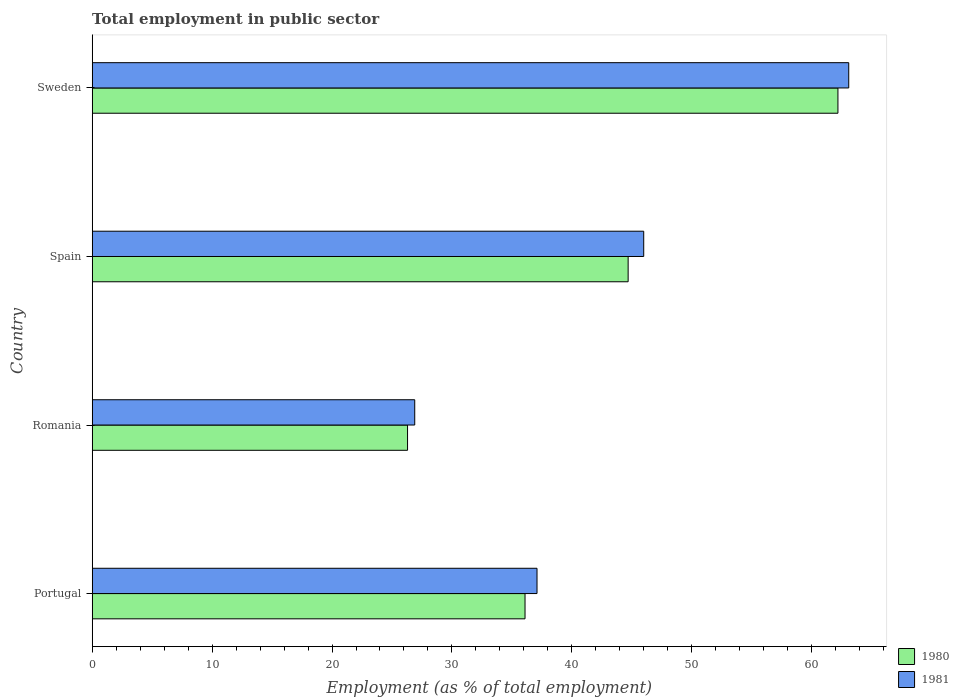How many different coloured bars are there?
Offer a terse response. 2. Are the number of bars on each tick of the Y-axis equal?
Provide a short and direct response. Yes. How many bars are there on the 2nd tick from the top?
Provide a short and direct response. 2. How many bars are there on the 1st tick from the bottom?
Keep it short and to the point. 2. What is the label of the 2nd group of bars from the top?
Keep it short and to the point. Spain. What is the employment in public sector in 1981 in Romania?
Provide a succinct answer. 26.9. Across all countries, what is the maximum employment in public sector in 1980?
Your answer should be compact. 62.2. Across all countries, what is the minimum employment in public sector in 1981?
Provide a short and direct response. 26.9. In which country was the employment in public sector in 1981 maximum?
Provide a succinct answer. Sweden. In which country was the employment in public sector in 1981 minimum?
Your answer should be very brief. Romania. What is the total employment in public sector in 1981 in the graph?
Keep it short and to the point. 173.1. What is the difference between the employment in public sector in 1980 in Portugal and that in Romania?
Provide a succinct answer. 9.8. What is the difference between the employment in public sector in 1980 in Spain and the employment in public sector in 1981 in Sweden?
Make the answer very short. -18.4. What is the average employment in public sector in 1980 per country?
Offer a terse response. 42.32. In how many countries, is the employment in public sector in 1980 greater than 16 %?
Keep it short and to the point. 4. What is the ratio of the employment in public sector in 1981 in Portugal to that in Sweden?
Your response must be concise. 0.59. Is the employment in public sector in 1981 in Romania less than that in Sweden?
Give a very brief answer. Yes. What is the difference between the highest and the second highest employment in public sector in 1981?
Ensure brevity in your answer.  17.1. What is the difference between the highest and the lowest employment in public sector in 1980?
Provide a short and direct response. 35.9. In how many countries, is the employment in public sector in 1980 greater than the average employment in public sector in 1980 taken over all countries?
Keep it short and to the point. 2. Are all the bars in the graph horizontal?
Offer a very short reply. Yes. How many countries are there in the graph?
Provide a short and direct response. 4. What is the difference between two consecutive major ticks on the X-axis?
Provide a short and direct response. 10. Does the graph contain any zero values?
Offer a very short reply. No. How many legend labels are there?
Offer a very short reply. 2. What is the title of the graph?
Provide a short and direct response. Total employment in public sector. What is the label or title of the X-axis?
Give a very brief answer. Employment (as % of total employment). What is the label or title of the Y-axis?
Offer a very short reply. Country. What is the Employment (as % of total employment) of 1980 in Portugal?
Provide a succinct answer. 36.1. What is the Employment (as % of total employment) of 1981 in Portugal?
Make the answer very short. 37.1. What is the Employment (as % of total employment) of 1980 in Romania?
Offer a terse response. 26.3. What is the Employment (as % of total employment) in 1981 in Romania?
Your answer should be very brief. 26.9. What is the Employment (as % of total employment) in 1980 in Spain?
Make the answer very short. 44.7. What is the Employment (as % of total employment) in 1980 in Sweden?
Provide a succinct answer. 62.2. What is the Employment (as % of total employment) of 1981 in Sweden?
Ensure brevity in your answer.  63.1. Across all countries, what is the maximum Employment (as % of total employment) of 1980?
Give a very brief answer. 62.2. Across all countries, what is the maximum Employment (as % of total employment) of 1981?
Provide a succinct answer. 63.1. Across all countries, what is the minimum Employment (as % of total employment) in 1980?
Give a very brief answer. 26.3. Across all countries, what is the minimum Employment (as % of total employment) of 1981?
Your response must be concise. 26.9. What is the total Employment (as % of total employment) of 1980 in the graph?
Provide a succinct answer. 169.3. What is the total Employment (as % of total employment) of 1981 in the graph?
Your response must be concise. 173.1. What is the difference between the Employment (as % of total employment) of 1980 in Portugal and that in Romania?
Ensure brevity in your answer.  9.8. What is the difference between the Employment (as % of total employment) in 1981 in Portugal and that in Romania?
Offer a very short reply. 10.2. What is the difference between the Employment (as % of total employment) in 1980 in Portugal and that in Spain?
Give a very brief answer. -8.6. What is the difference between the Employment (as % of total employment) of 1980 in Portugal and that in Sweden?
Keep it short and to the point. -26.1. What is the difference between the Employment (as % of total employment) in 1980 in Romania and that in Spain?
Provide a short and direct response. -18.4. What is the difference between the Employment (as % of total employment) of 1981 in Romania and that in Spain?
Provide a succinct answer. -19.1. What is the difference between the Employment (as % of total employment) of 1980 in Romania and that in Sweden?
Your answer should be very brief. -35.9. What is the difference between the Employment (as % of total employment) of 1981 in Romania and that in Sweden?
Provide a short and direct response. -36.2. What is the difference between the Employment (as % of total employment) of 1980 in Spain and that in Sweden?
Your response must be concise. -17.5. What is the difference between the Employment (as % of total employment) in 1981 in Spain and that in Sweden?
Offer a very short reply. -17.1. What is the difference between the Employment (as % of total employment) in 1980 in Portugal and the Employment (as % of total employment) in 1981 in Romania?
Keep it short and to the point. 9.2. What is the difference between the Employment (as % of total employment) in 1980 in Portugal and the Employment (as % of total employment) in 1981 in Sweden?
Provide a short and direct response. -27. What is the difference between the Employment (as % of total employment) of 1980 in Romania and the Employment (as % of total employment) of 1981 in Spain?
Provide a succinct answer. -19.7. What is the difference between the Employment (as % of total employment) in 1980 in Romania and the Employment (as % of total employment) in 1981 in Sweden?
Provide a short and direct response. -36.8. What is the difference between the Employment (as % of total employment) in 1980 in Spain and the Employment (as % of total employment) in 1981 in Sweden?
Ensure brevity in your answer.  -18.4. What is the average Employment (as % of total employment) in 1980 per country?
Offer a terse response. 42.33. What is the average Employment (as % of total employment) in 1981 per country?
Give a very brief answer. 43.27. What is the difference between the Employment (as % of total employment) of 1980 and Employment (as % of total employment) of 1981 in Spain?
Ensure brevity in your answer.  -1.3. What is the ratio of the Employment (as % of total employment) in 1980 in Portugal to that in Romania?
Your answer should be very brief. 1.37. What is the ratio of the Employment (as % of total employment) in 1981 in Portugal to that in Romania?
Give a very brief answer. 1.38. What is the ratio of the Employment (as % of total employment) in 1980 in Portugal to that in Spain?
Your answer should be very brief. 0.81. What is the ratio of the Employment (as % of total employment) in 1981 in Portugal to that in Spain?
Your answer should be very brief. 0.81. What is the ratio of the Employment (as % of total employment) in 1980 in Portugal to that in Sweden?
Provide a succinct answer. 0.58. What is the ratio of the Employment (as % of total employment) in 1981 in Portugal to that in Sweden?
Offer a very short reply. 0.59. What is the ratio of the Employment (as % of total employment) in 1980 in Romania to that in Spain?
Give a very brief answer. 0.59. What is the ratio of the Employment (as % of total employment) of 1981 in Romania to that in Spain?
Give a very brief answer. 0.58. What is the ratio of the Employment (as % of total employment) in 1980 in Romania to that in Sweden?
Your answer should be very brief. 0.42. What is the ratio of the Employment (as % of total employment) in 1981 in Romania to that in Sweden?
Make the answer very short. 0.43. What is the ratio of the Employment (as % of total employment) in 1980 in Spain to that in Sweden?
Give a very brief answer. 0.72. What is the ratio of the Employment (as % of total employment) of 1981 in Spain to that in Sweden?
Provide a short and direct response. 0.73. What is the difference between the highest and the second highest Employment (as % of total employment) of 1980?
Provide a short and direct response. 17.5. What is the difference between the highest and the lowest Employment (as % of total employment) of 1980?
Make the answer very short. 35.9. What is the difference between the highest and the lowest Employment (as % of total employment) in 1981?
Offer a terse response. 36.2. 